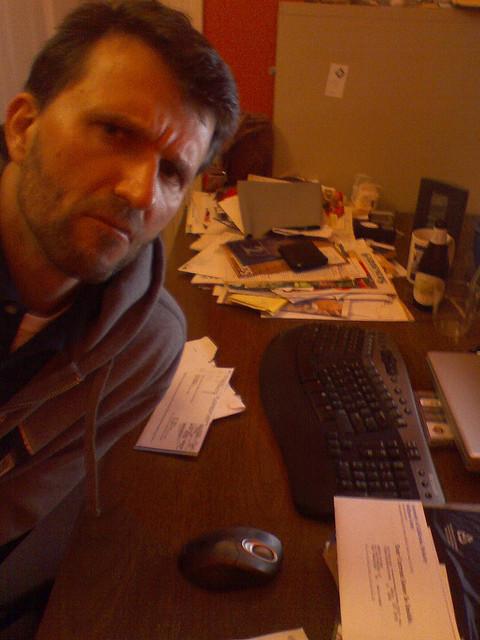How many of the papers in this photo look like bills?
Short answer required. 2. Is the man happy?
Be succinct. No. Is the desk organized?
Give a very brief answer. No. 